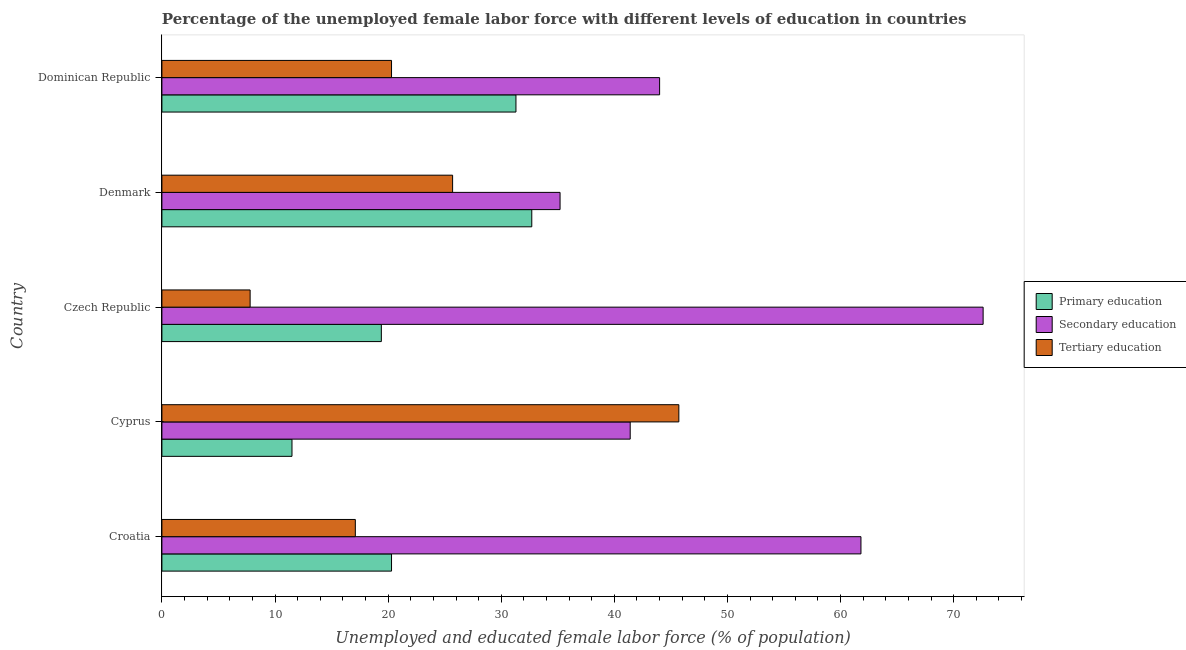How many different coloured bars are there?
Keep it short and to the point. 3. Are the number of bars per tick equal to the number of legend labels?
Give a very brief answer. Yes. Are the number of bars on each tick of the Y-axis equal?
Keep it short and to the point. Yes. How many bars are there on the 4th tick from the top?
Provide a succinct answer. 3. How many bars are there on the 1st tick from the bottom?
Your answer should be very brief. 3. What is the label of the 4th group of bars from the top?
Your answer should be compact. Cyprus. What is the percentage of female labor force who received tertiary education in Dominican Republic?
Offer a terse response. 20.3. Across all countries, what is the maximum percentage of female labor force who received tertiary education?
Offer a very short reply. 45.7. Across all countries, what is the minimum percentage of female labor force who received secondary education?
Give a very brief answer. 35.2. In which country was the percentage of female labor force who received secondary education maximum?
Make the answer very short. Czech Republic. In which country was the percentage of female labor force who received primary education minimum?
Provide a short and direct response. Cyprus. What is the total percentage of female labor force who received tertiary education in the graph?
Offer a terse response. 116.6. What is the difference between the percentage of female labor force who received secondary education in Croatia and that in Cyprus?
Provide a succinct answer. 20.4. What is the difference between the percentage of female labor force who received primary education in Czech Republic and the percentage of female labor force who received tertiary education in Croatia?
Your response must be concise. 2.3. What is the average percentage of female labor force who received primary education per country?
Make the answer very short. 23.04. In how many countries, is the percentage of female labor force who received secondary education greater than 20 %?
Offer a very short reply. 5. What is the ratio of the percentage of female labor force who received tertiary education in Croatia to that in Dominican Republic?
Your answer should be compact. 0.84. What is the difference between the highest and the second highest percentage of female labor force who received primary education?
Offer a terse response. 1.4. What is the difference between the highest and the lowest percentage of female labor force who received tertiary education?
Keep it short and to the point. 37.9. In how many countries, is the percentage of female labor force who received tertiary education greater than the average percentage of female labor force who received tertiary education taken over all countries?
Give a very brief answer. 2. What does the 1st bar from the top in Croatia represents?
Ensure brevity in your answer.  Tertiary education. What does the 3rd bar from the bottom in Czech Republic represents?
Your answer should be compact. Tertiary education. How many bars are there?
Keep it short and to the point. 15. How many countries are there in the graph?
Offer a very short reply. 5. Are the values on the major ticks of X-axis written in scientific E-notation?
Keep it short and to the point. No. Does the graph contain any zero values?
Provide a short and direct response. No. Does the graph contain grids?
Your response must be concise. No. How are the legend labels stacked?
Your response must be concise. Vertical. What is the title of the graph?
Ensure brevity in your answer.  Percentage of the unemployed female labor force with different levels of education in countries. Does "Services" appear as one of the legend labels in the graph?
Offer a very short reply. No. What is the label or title of the X-axis?
Your response must be concise. Unemployed and educated female labor force (% of population). What is the label or title of the Y-axis?
Provide a short and direct response. Country. What is the Unemployed and educated female labor force (% of population) of Primary education in Croatia?
Offer a terse response. 20.3. What is the Unemployed and educated female labor force (% of population) of Secondary education in Croatia?
Give a very brief answer. 61.8. What is the Unemployed and educated female labor force (% of population) in Tertiary education in Croatia?
Offer a very short reply. 17.1. What is the Unemployed and educated female labor force (% of population) in Secondary education in Cyprus?
Ensure brevity in your answer.  41.4. What is the Unemployed and educated female labor force (% of population) in Tertiary education in Cyprus?
Give a very brief answer. 45.7. What is the Unemployed and educated female labor force (% of population) in Primary education in Czech Republic?
Make the answer very short. 19.4. What is the Unemployed and educated female labor force (% of population) in Secondary education in Czech Republic?
Offer a terse response. 72.6. What is the Unemployed and educated female labor force (% of population) in Tertiary education in Czech Republic?
Offer a terse response. 7.8. What is the Unemployed and educated female labor force (% of population) in Primary education in Denmark?
Your response must be concise. 32.7. What is the Unemployed and educated female labor force (% of population) of Secondary education in Denmark?
Offer a very short reply. 35.2. What is the Unemployed and educated female labor force (% of population) in Tertiary education in Denmark?
Keep it short and to the point. 25.7. What is the Unemployed and educated female labor force (% of population) in Primary education in Dominican Republic?
Give a very brief answer. 31.3. What is the Unemployed and educated female labor force (% of population) in Secondary education in Dominican Republic?
Your answer should be compact. 44. What is the Unemployed and educated female labor force (% of population) of Tertiary education in Dominican Republic?
Your response must be concise. 20.3. Across all countries, what is the maximum Unemployed and educated female labor force (% of population) of Primary education?
Make the answer very short. 32.7. Across all countries, what is the maximum Unemployed and educated female labor force (% of population) of Secondary education?
Ensure brevity in your answer.  72.6. Across all countries, what is the maximum Unemployed and educated female labor force (% of population) in Tertiary education?
Ensure brevity in your answer.  45.7. Across all countries, what is the minimum Unemployed and educated female labor force (% of population) of Secondary education?
Your answer should be compact. 35.2. Across all countries, what is the minimum Unemployed and educated female labor force (% of population) of Tertiary education?
Provide a succinct answer. 7.8. What is the total Unemployed and educated female labor force (% of population) of Primary education in the graph?
Your answer should be compact. 115.2. What is the total Unemployed and educated female labor force (% of population) of Secondary education in the graph?
Your response must be concise. 255. What is the total Unemployed and educated female labor force (% of population) of Tertiary education in the graph?
Your answer should be very brief. 116.6. What is the difference between the Unemployed and educated female labor force (% of population) of Primary education in Croatia and that in Cyprus?
Provide a succinct answer. 8.8. What is the difference between the Unemployed and educated female labor force (% of population) of Secondary education in Croatia and that in Cyprus?
Provide a short and direct response. 20.4. What is the difference between the Unemployed and educated female labor force (% of population) of Tertiary education in Croatia and that in Cyprus?
Offer a terse response. -28.6. What is the difference between the Unemployed and educated female labor force (% of population) of Primary education in Croatia and that in Czech Republic?
Offer a terse response. 0.9. What is the difference between the Unemployed and educated female labor force (% of population) in Secondary education in Croatia and that in Czech Republic?
Ensure brevity in your answer.  -10.8. What is the difference between the Unemployed and educated female labor force (% of population) of Primary education in Croatia and that in Denmark?
Make the answer very short. -12.4. What is the difference between the Unemployed and educated female labor force (% of population) in Secondary education in Croatia and that in Denmark?
Your answer should be very brief. 26.6. What is the difference between the Unemployed and educated female labor force (% of population) in Tertiary education in Croatia and that in Denmark?
Your response must be concise. -8.6. What is the difference between the Unemployed and educated female labor force (% of population) in Primary education in Croatia and that in Dominican Republic?
Keep it short and to the point. -11. What is the difference between the Unemployed and educated female labor force (% of population) of Secondary education in Croatia and that in Dominican Republic?
Offer a terse response. 17.8. What is the difference between the Unemployed and educated female labor force (% of population) in Secondary education in Cyprus and that in Czech Republic?
Keep it short and to the point. -31.2. What is the difference between the Unemployed and educated female labor force (% of population) in Tertiary education in Cyprus and that in Czech Republic?
Keep it short and to the point. 37.9. What is the difference between the Unemployed and educated female labor force (% of population) in Primary education in Cyprus and that in Denmark?
Give a very brief answer. -21.2. What is the difference between the Unemployed and educated female labor force (% of population) of Tertiary education in Cyprus and that in Denmark?
Give a very brief answer. 20. What is the difference between the Unemployed and educated female labor force (% of population) of Primary education in Cyprus and that in Dominican Republic?
Offer a terse response. -19.8. What is the difference between the Unemployed and educated female labor force (% of population) in Secondary education in Cyprus and that in Dominican Republic?
Ensure brevity in your answer.  -2.6. What is the difference between the Unemployed and educated female labor force (% of population) in Tertiary education in Cyprus and that in Dominican Republic?
Your answer should be compact. 25.4. What is the difference between the Unemployed and educated female labor force (% of population) in Primary education in Czech Republic and that in Denmark?
Provide a succinct answer. -13.3. What is the difference between the Unemployed and educated female labor force (% of population) in Secondary education in Czech Republic and that in Denmark?
Provide a succinct answer. 37.4. What is the difference between the Unemployed and educated female labor force (% of population) of Tertiary education in Czech Republic and that in Denmark?
Offer a terse response. -17.9. What is the difference between the Unemployed and educated female labor force (% of population) of Secondary education in Czech Republic and that in Dominican Republic?
Your answer should be very brief. 28.6. What is the difference between the Unemployed and educated female labor force (% of population) in Tertiary education in Czech Republic and that in Dominican Republic?
Provide a succinct answer. -12.5. What is the difference between the Unemployed and educated female labor force (% of population) of Secondary education in Denmark and that in Dominican Republic?
Ensure brevity in your answer.  -8.8. What is the difference between the Unemployed and educated female labor force (% of population) of Primary education in Croatia and the Unemployed and educated female labor force (% of population) of Secondary education in Cyprus?
Your answer should be very brief. -21.1. What is the difference between the Unemployed and educated female labor force (% of population) in Primary education in Croatia and the Unemployed and educated female labor force (% of population) in Tertiary education in Cyprus?
Offer a very short reply. -25.4. What is the difference between the Unemployed and educated female labor force (% of population) in Primary education in Croatia and the Unemployed and educated female labor force (% of population) in Secondary education in Czech Republic?
Give a very brief answer. -52.3. What is the difference between the Unemployed and educated female labor force (% of population) in Secondary education in Croatia and the Unemployed and educated female labor force (% of population) in Tertiary education in Czech Republic?
Your response must be concise. 54. What is the difference between the Unemployed and educated female labor force (% of population) of Primary education in Croatia and the Unemployed and educated female labor force (% of population) of Secondary education in Denmark?
Give a very brief answer. -14.9. What is the difference between the Unemployed and educated female labor force (% of population) in Secondary education in Croatia and the Unemployed and educated female labor force (% of population) in Tertiary education in Denmark?
Your response must be concise. 36.1. What is the difference between the Unemployed and educated female labor force (% of population) in Primary education in Croatia and the Unemployed and educated female labor force (% of population) in Secondary education in Dominican Republic?
Your answer should be compact. -23.7. What is the difference between the Unemployed and educated female labor force (% of population) in Primary education in Croatia and the Unemployed and educated female labor force (% of population) in Tertiary education in Dominican Republic?
Your response must be concise. 0. What is the difference between the Unemployed and educated female labor force (% of population) in Secondary education in Croatia and the Unemployed and educated female labor force (% of population) in Tertiary education in Dominican Republic?
Ensure brevity in your answer.  41.5. What is the difference between the Unemployed and educated female labor force (% of population) of Primary education in Cyprus and the Unemployed and educated female labor force (% of population) of Secondary education in Czech Republic?
Your answer should be compact. -61.1. What is the difference between the Unemployed and educated female labor force (% of population) in Secondary education in Cyprus and the Unemployed and educated female labor force (% of population) in Tertiary education in Czech Republic?
Provide a short and direct response. 33.6. What is the difference between the Unemployed and educated female labor force (% of population) in Primary education in Cyprus and the Unemployed and educated female labor force (% of population) in Secondary education in Denmark?
Offer a very short reply. -23.7. What is the difference between the Unemployed and educated female labor force (% of population) in Primary education in Cyprus and the Unemployed and educated female labor force (% of population) in Tertiary education in Denmark?
Give a very brief answer. -14.2. What is the difference between the Unemployed and educated female labor force (% of population) in Primary education in Cyprus and the Unemployed and educated female labor force (% of population) in Secondary education in Dominican Republic?
Your response must be concise. -32.5. What is the difference between the Unemployed and educated female labor force (% of population) in Primary education in Cyprus and the Unemployed and educated female labor force (% of population) in Tertiary education in Dominican Republic?
Offer a very short reply. -8.8. What is the difference between the Unemployed and educated female labor force (% of population) in Secondary education in Cyprus and the Unemployed and educated female labor force (% of population) in Tertiary education in Dominican Republic?
Give a very brief answer. 21.1. What is the difference between the Unemployed and educated female labor force (% of population) in Primary education in Czech Republic and the Unemployed and educated female labor force (% of population) in Secondary education in Denmark?
Your answer should be very brief. -15.8. What is the difference between the Unemployed and educated female labor force (% of population) of Secondary education in Czech Republic and the Unemployed and educated female labor force (% of population) of Tertiary education in Denmark?
Your response must be concise. 46.9. What is the difference between the Unemployed and educated female labor force (% of population) in Primary education in Czech Republic and the Unemployed and educated female labor force (% of population) in Secondary education in Dominican Republic?
Keep it short and to the point. -24.6. What is the difference between the Unemployed and educated female labor force (% of population) in Secondary education in Czech Republic and the Unemployed and educated female labor force (% of population) in Tertiary education in Dominican Republic?
Provide a short and direct response. 52.3. What is the difference between the Unemployed and educated female labor force (% of population) in Secondary education in Denmark and the Unemployed and educated female labor force (% of population) in Tertiary education in Dominican Republic?
Make the answer very short. 14.9. What is the average Unemployed and educated female labor force (% of population) in Primary education per country?
Your response must be concise. 23.04. What is the average Unemployed and educated female labor force (% of population) in Secondary education per country?
Offer a terse response. 51. What is the average Unemployed and educated female labor force (% of population) in Tertiary education per country?
Offer a terse response. 23.32. What is the difference between the Unemployed and educated female labor force (% of population) in Primary education and Unemployed and educated female labor force (% of population) in Secondary education in Croatia?
Provide a succinct answer. -41.5. What is the difference between the Unemployed and educated female labor force (% of population) in Primary education and Unemployed and educated female labor force (% of population) in Tertiary education in Croatia?
Your response must be concise. 3.2. What is the difference between the Unemployed and educated female labor force (% of population) in Secondary education and Unemployed and educated female labor force (% of population) in Tertiary education in Croatia?
Your answer should be very brief. 44.7. What is the difference between the Unemployed and educated female labor force (% of population) in Primary education and Unemployed and educated female labor force (% of population) in Secondary education in Cyprus?
Make the answer very short. -29.9. What is the difference between the Unemployed and educated female labor force (% of population) in Primary education and Unemployed and educated female labor force (% of population) in Tertiary education in Cyprus?
Ensure brevity in your answer.  -34.2. What is the difference between the Unemployed and educated female labor force (% of population) of Primary education and Unemployed and educated female labor force (% of population) of Secondary education in Czech Republic?
Offer a very short reply. -53.2. What is the difference between the Unemployed and educated female labor force (% of population) in Primary education and Unemployed and educated female labor force (% of population) in Tertiary education in Czech Republic?
Provide a succinct answer. 11.6. What is the difference between the Unemployed and educated female labor force (% of population) in Secondary education and Unemployed and educated female labor force (% of population) in Tertiary education in Czech Republic?
Give a very brief answer. 64.8. What is the difference between the Unemployed and educated female labor force (% of population) in Primary education and Unemployed and educated female labor force (% of population) in Secondary education in Denmark?
Your answer should be compact. -2.5. What is the difference between the Unemployed and educated female labor force (% of population) of Primary education and Unemployed and educated female labor force (% of population) of Tertiary education in Denmark?
Give a very brief answer. 7. What is the difference between the Unemployed and educated female labor force (% of population) in Secondary education and Unemployed and educated female labor force (% of population) in Tertiary education in Denmark?
Give a very brief answer. 9.5. What is the difference between the Unemployed and educated female labor force (% of population) of Primary education and Unemployed and educated female labor force (% of population) of Secondary education in Dominican Republic?
Give a very brief answer. -12.7. What is the difference between the Unemployed and educated female labor force (% of population) in Secondary education and Unemployed and educated female labor force (% of population) in Tertiary education in Dominican Republic?
Keep it short and to the point. 23.7. What is the ratio of the Unemployed and educated female labor force (% of population) in Primary education in Croatia to that in Cyprus?
Provide a succinct answer. 1.77. What is the ratio of the Unemployed and educated female labor force (% of population) of Secondary education in Croatia to that in Cyprus?
Offer a very short reply. 1.49. What is the ratio of the Unemployed and educated female labor force (% of population) in Tertiary education in Croatia to that in Cyprus?
Make the answer very short. 0.37. What is the ratio of the Unemployed and educated female labor force (% of population) in Primary education in Croatia to that in Czech Republic?
Keep it short and to the point. 1.05. What is the ratio of the Unemployed and educated female labor force (% of population) of Secondary education in Croatia to that in Czech Republic?
Make the answer very short. 0.85. What is the ratio of the Unemployed and educated female labor force (% of population) in Tertiary education in Croatia to that in Czech Republic?
Your answer should be compact. 2.19. What is the ratio of the Unemployed and educated female labor force (% of population) of Primary education in Croatia to that in Denmark?
Your answer should be compact. 0.62. What is the ratio of the Unemployed and educated female labor force (% of population) in Secondary education in Croatia to that in Denmark?
Your answer should be very brief. 1.76. What is the ratio of the Unemployed and educated female labor force (% of population) in Tertiary education in Croatia to that in Denmark?
Make the answer very short. 0.67. What is the ratio of the Unemployed and educated female labor force (% of population) of Primary education in Croatia to that in Dominican Republic?
Give a very brief answer. 0.65. What is the ratio of the Unemployed and educated female labor force (% of population) of Secondary education in Croatia to that in Dominican Republic?
Ensure brevity in your answer.  1.4. What is the ratio of the Unemployed and educated female labor force (% of population) of Tertiary education in Croatia to that in Dominican Republic?
Provide a succinct answer. 0.84. What is the ratio of the Unemployed and educated female labor force (% of population) in Primary education in Cyprus to that in Czech Republic?
Keep it short and to the point. 0.59. What is the ratio of the Unemployed and educated female labor force (% of population) of Secondary education in Cyprus to that in Czech Republic?
Your answer should be compact. 0.57. What is the ratio of the Unemployed and educated female labor force (% of population) in Tertiary education in Cyprus to that in Czech Republic?
Make the answer very short. 5.86. What is the ratio of the Unemployed and educated female labor force (% of population) in Primary education in Cyprus to that in Denmark?
Ensure brevity in your answer.  0.35. What is the ratio of the Unemployed and educated female labor force (% of population) of Secondary education in Cyprus to that in Denmark?
Provide a short and direct response. 1.18. What is the ratio of the Unemployed and educated female labor force (% of population) in Tertiary education in Cyprus to that in Denmark?
Your answer should be very brief. 1.78. What is the ratio of the Unemployed and educated female labor force (% of population) of Primary education in Cyprus to that in Dominican Republic?
Your response must be concise. 0.37. What is the ratio of the Unemployed and educated female labor force (% of population) of Secondary education in Cyprus to that in Dominican Republic?
Make the answer very short. 0.94. What is the ratio of the Unemployed and educated female labor force (% of population) of Tertiary education in Cyprus to that in Dominican Republic?
Your answer should be compact. 2.25. What is the ratio of the Unemployed and educated female labor force (% of population) of Primary education in Czech Republic to that in Denmark?
Provide a succinct answer. 0.59. What is the ratio of the Unemployed and educated female labor force (% of population) of Secondary education in Czech Republic to that in Denmark?
Offer a terse response. 2.06. What is the ratio of the Unemployed and educated female labor force (% of population) of Tertiary education in Czech Republic to that in Denmark?
Offer a terse response. 0.3. What is the ratio of the Unemployed and educated female labor force (% of population) of Primary education in Czech Republic to that in Dominican Republic?
Ensure brevity in your answer.  0.62. What is the ratio of the Unemployed and educated female labor force (% of population) in Secondary education in Czech Republic to that in Dominican Republic?
Offer a very short reply. 1.65. What is the ratio of the Unemployed and educated female labor force (% of population) in Tertiary education in Czech Republic to that in Dominican Republic?
Your answer should be very brief. 0.38. What is the ratio of the Unemployed and educated female labor force (% of population) of Primary education in Denmark to that in Dominican Republic?
Your response must be concise. 1.04. What is the ratio of the Unemployed and educated female labor force (% of population) in Tertiary education in Denmark to that in Dominican Republic?
Ensure brevity in your answer.  1.27. What is the difference between the highest and the lowest Unemployed and educated female labor force (% of population) of Primary education?
Make the answer very short. 21.2. What is the difference between the highest and the lowest Unemployed and educated female labor force (% of population) of Secondary education?
Provide a short and direct response. 37.4. What is the difference between the highest and the lowest Unemployed and educated female labor force (% of population) in Tertiary education?
Keep it short and to the point. 37.9. 